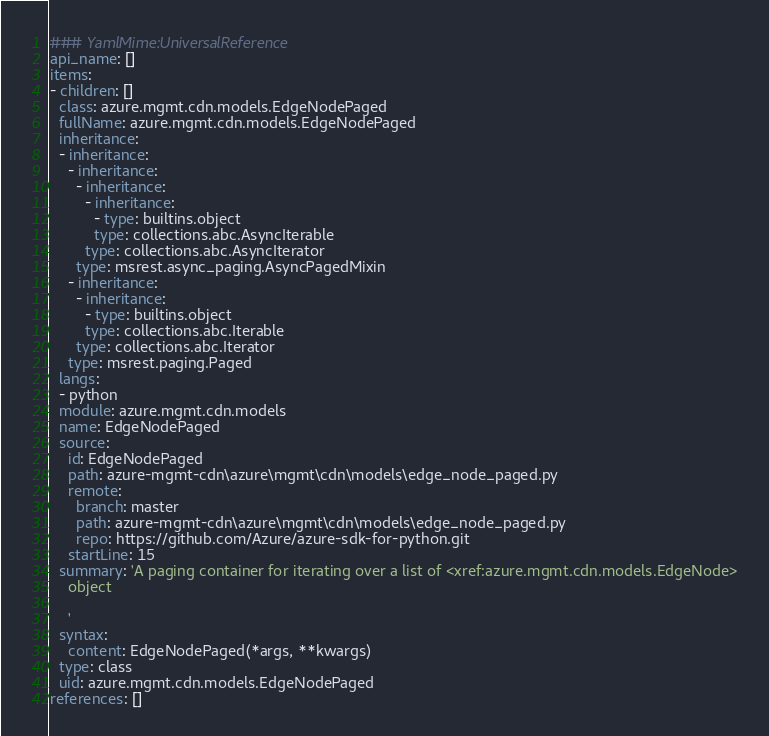Convert code to text. <code><loc_0><loc_0><loc_500><loc_500><_YAML_>### YamlMime:UniversalReference
api_name: []
items:
- children: []
  class: azure.mgmt.cdn.models.EdgeNodePaged
  fullName: azure.mgmt.cdn.models.EdgeNodePaged
  inheritance:
  - inheritance:
    - inheritance:
      - inheritance:
        - inheritance:
          - type: builtins.object
          type: collections.abc.AsyncIterable
        type: collections.abc.AsyncIterator
      type: msrest.async_paging.AsyncPagedMixin
    - inheritance:
      - inheritance:
        - type: builtins.object
        type: collections.abc.Iterable
      type: collections.abc.Iterator
    type: msrest.paging.Paged
  langs:
  - python
  module: azure.mgmt.cdn.models
  name: EdgeNodePaged
  source:
    id: EdgeNodePaged
    path: azure-mgmt-cdn\azure\mgmt\cdn\models\edge_node_paged.py
    remote:
      branch: master
      path: azure-mgmt-cdn\azure\mgmt\cdn\models\edge_node_paged.py
      repo: https://github.com/Azure/azure-sdk-for-python.git
    startLine: 15
  summary: 'A paging container for iterating over a list of <xref:azure.mgmt.cdn.models.EdgeNode>
    object

    '
  syntax:
    content: EdgeNodePaged(*args, **kwargs)
  type: class
  uid: azure.mgmt.cdn.models.EdgeNodePaged
references: []
</code> 